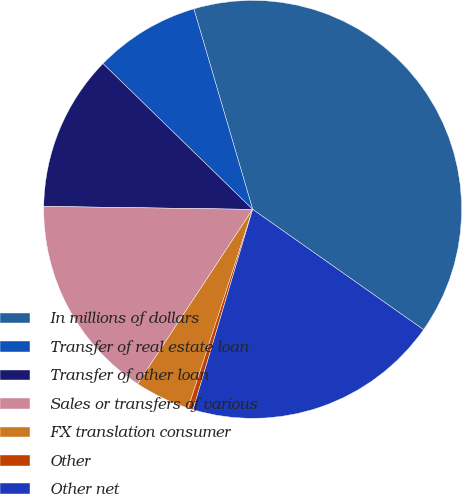Convert chart to OTSL. <chart><loc_0><loc_0><loc_500><loc_500><pie_chart><fcel>In millions of dollars<fcel>Transfer of real estate loan<fcel>Transfer of other loan<fcel>Sales or transfers of various<fcel>FX translation consumer<fcel>Other<fcel>Other net<nl><fcel>39.3%<fcel>8.17%<fcel>12.06%<fcel>15.95%<fcel>4.28%<fcel>0.39%<fcel>19.84%<nl></chart> 